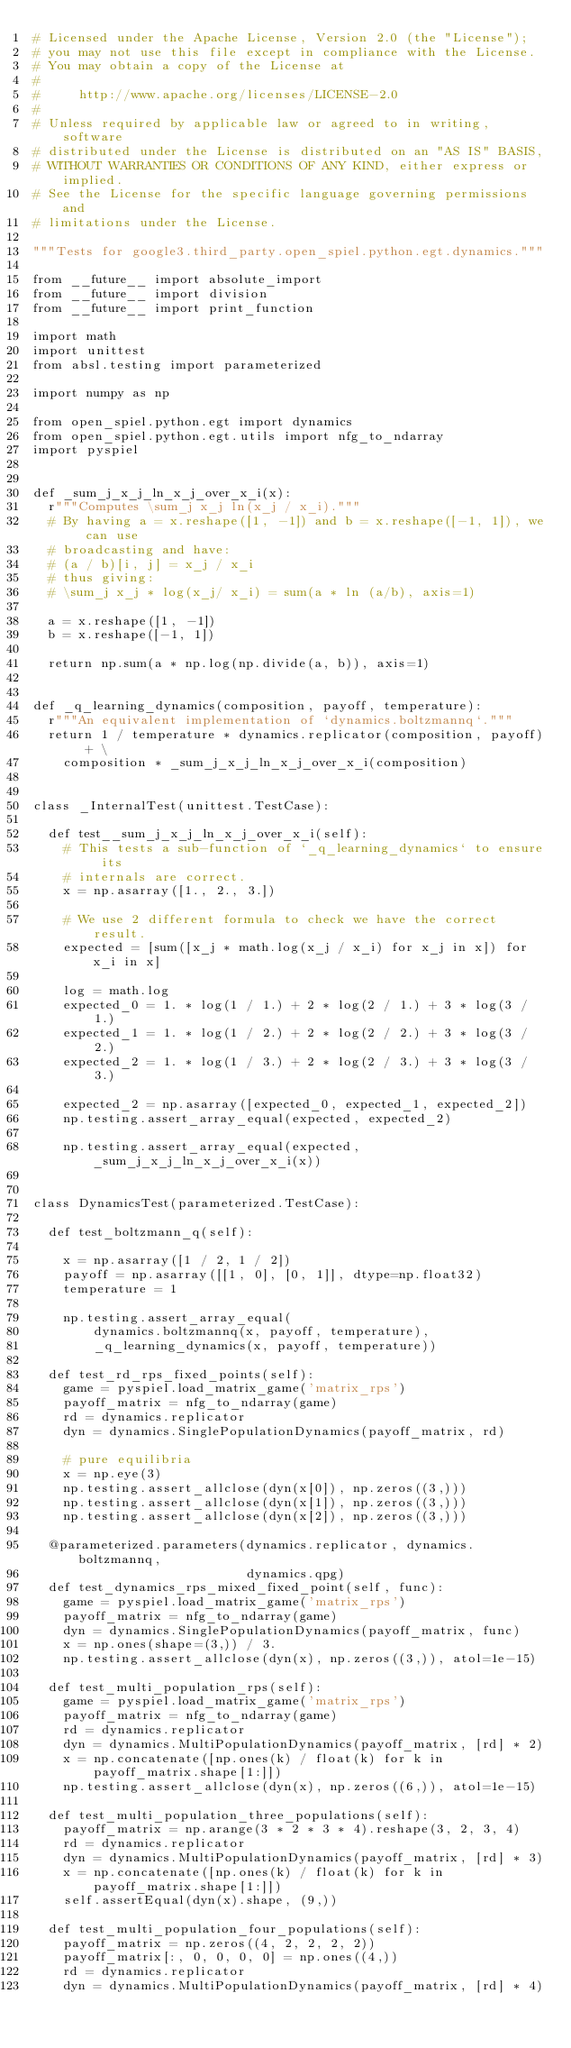Convert code to text. <code><loc_0><loc_0><loc_500><loc_500><_Python_># Licensed under the Apache License, Version 2.0 (the "License");
# you may not use this file except in compliance with the License.
# You may obtain a copy of the License at
#
#     http://www.apache.org/licenses/LICENSE-2.0
#
# Unless required by applicable law or agreed to in writing, software
# distributed under the License is distributed on an "AS IS" BASIS,
# WITHOUT WARRANTIES OR CONDITIONS OF ANY KIND, either express or implied.
# See the License for the specific language governing permissions and
# limitations under the License.

"""Tests for google3.third_party.open_spiel.python.egt.dynamics."""

from __future__ import absolute_import
from __future__ import division
from __future__ import print_function

import math
import unittest
from absl.testing import parameterized

import numpy as np

from open_spiel.python.egt import dynamics
from open_spiel.python.egt.utils import nfg_to_ndarray
import pyspiel


def _sum_j_x_j_ln_x_j_over_x_i(x):
  r"""Computes \sum_j x_j ln(x_j / x_i)."""
  # By having a = x.reshape([1, -1]) and b = x.reshape([-1, 1]), we can use
  # broadcasting and have:
  # (a / b)[i, j] = x_j / x_i
  # thus giving:
  # \sum_j x_j * log(x_j/ x_i) = sum(a * ln (a/b), axis=1)

  a = x.reshape([1, -1])
  b = x.reshape([-1, 1])

  return np.sum(a * np.log(np.divide(a, b)), axis=1)


def _q_learning_dynamics(composition, payoff, temperature):
  r"""An equivalent implementation of `dynamics.boltzmannq`."""
  return 1 / temperature * dynamics.replicator(composition, payoff) + \
    composition * _sum_j_x_j_ln_x_j_over_x_i(composition)


class _InternalTest(unittest.TestCase):

  def test__sum_j_x_j_ln_x_j_over_x_i(self):
    # This tests a sub-function of `_q_learning_dynamics` to ensure its
    # internals are correct.
    x = np.asarray([1., 2., 3.])

    # We use 2 different formula to check we have the correct result.
    expected = [sum([x_j * math.log(x_j / x_i) for x_j in x]) for x_i in x]

    log = math.log
    expected_0 = 1. * log(1 / 1.) + 2 * log(2 / 1.) + 3 * log(3 / 1.)
    expected_1 = 1. * log(1 / 2.) + 2 * log(2 / 2.) + 3 * log(3 / 2.)
    expected_2 = 1. * log(1 / 3.) + 2 * log(2 / 3.) + 3 * log(3 / 3.)

    expected_2 = np.asarray([expected_0, expected_1, expected_2])
    np.testing.assert_array_equal(expected, expected_2)

    np.testing.assert_array_equal(expected, _sum_j_x_j_ln_x_j_over_x_i(x))


class DynamicsTest(parameterized.TestCase):

  def test_boltzmann_q(self):

    x = np.asarray([1 / 2, 1 / 2])
    payoff = np.asarray([[1, 0], [0, 1]], dtype=np.float32)
    temperature = 1

    np.testing.assert_array_equal(
        dynamics.boltzmannq(x, payoff, temperature),
        _q_learning_dynamics(x, payoff, temperature))

  def test_rd_rps_fixed_points(self):
    game = pyspiel.load_matrix_game('matrix_rps')
    payoff_matrix = nfg_to_ndarray(game)
    rd = dynamics.replicator
    dyn = dynamics.SinglePopulationDynamics(payoff_matrix, rd)

    # pure equilibria
    x = np.eye(3)
    np.testing.assert_allclose(dyn(x[0]), np.zeros((3,)))
    np.testing.assert_allclose(dyn(x[1]), np.zeros((3,)))
    np.testing.assert_allclose(dyn(x[2]), np.zeros((3,)))

  @parameterized.parameters(dynamics.replicator, dynamics.boltzmannq,
                            dynamics.qpg)
  def test_dynamics_rps_mixed_fixed_point(self, func):
    game = pyspiel.load_matrix_game('matrix_rps')
    payoff_matrix = nfg_to_ndarray(game)
    dyn = dynamics.SinglePopulationDynamics(payoff_matrix, func)
    x = np.ones(shape=(3,)) / 3.
    np.testing.assert_allclose(dyn(x), np.zeros((3,)), atol=1e-15)

  def test_multi_population_rps(self):
    game = pyspiel.load_matrix_game('matrix_rps')
    payoff_matrix = nfg_to_ndarray(game)
    rd = dynamics.replicator
    dyn = dynamics.MultiPopulationDynamics(payoff_matrix, [rd] * 2)
    x = np.concatenate([np.ones(k) / float(k) for k in payoff_matrix.shape[1:]])
    np.testing.assert_allclose(dyn(x), np.zeros((6,)), atol=1e-15)

  def test_multi_population_three_populations(self):
    payoff_matrix = np.arange(3 * 2 * 3 * 4).reshape(3, 2, 3, 4)
    rd = dynamics.replicator
    dyn = dynamics.MultiPopulationDynamics(payoff_matrix, [rd] * 3)
    x = np.concatenate([np.ones(k) / float(k) for k in payoff_matrix.shape[1:]])
    self.assertEqual(dyn(x).shape, (9,))

  def test_multi_population_four_populations(self):
    payoff_matrix = np.zeros((4, 2, 2, 2, 2))
    payoff_matrix[:, 0, 0, 0, 0] = np.ones((4,))
    rd = dynamics.replicator
    dyn = dynamics.MultiPopulationDynamics(payoff_matrix, [rd] * 4)</code> 